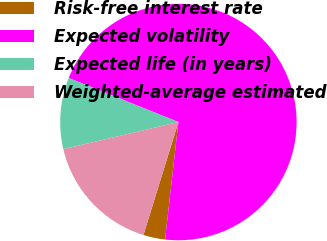Convert chart to OTSL. <chart><loc_0><loc_0><loc_500><loc_500><pie_chart><fcel>Risk-free interest rate<fcel>Expected volatility<fcel>Expected life (in years)<fcel>Weighted-average estimated<nl><fcel>2.98%<fcel>70.73%<fcel>9.76%<fcel>16.54%<nl></chart> 